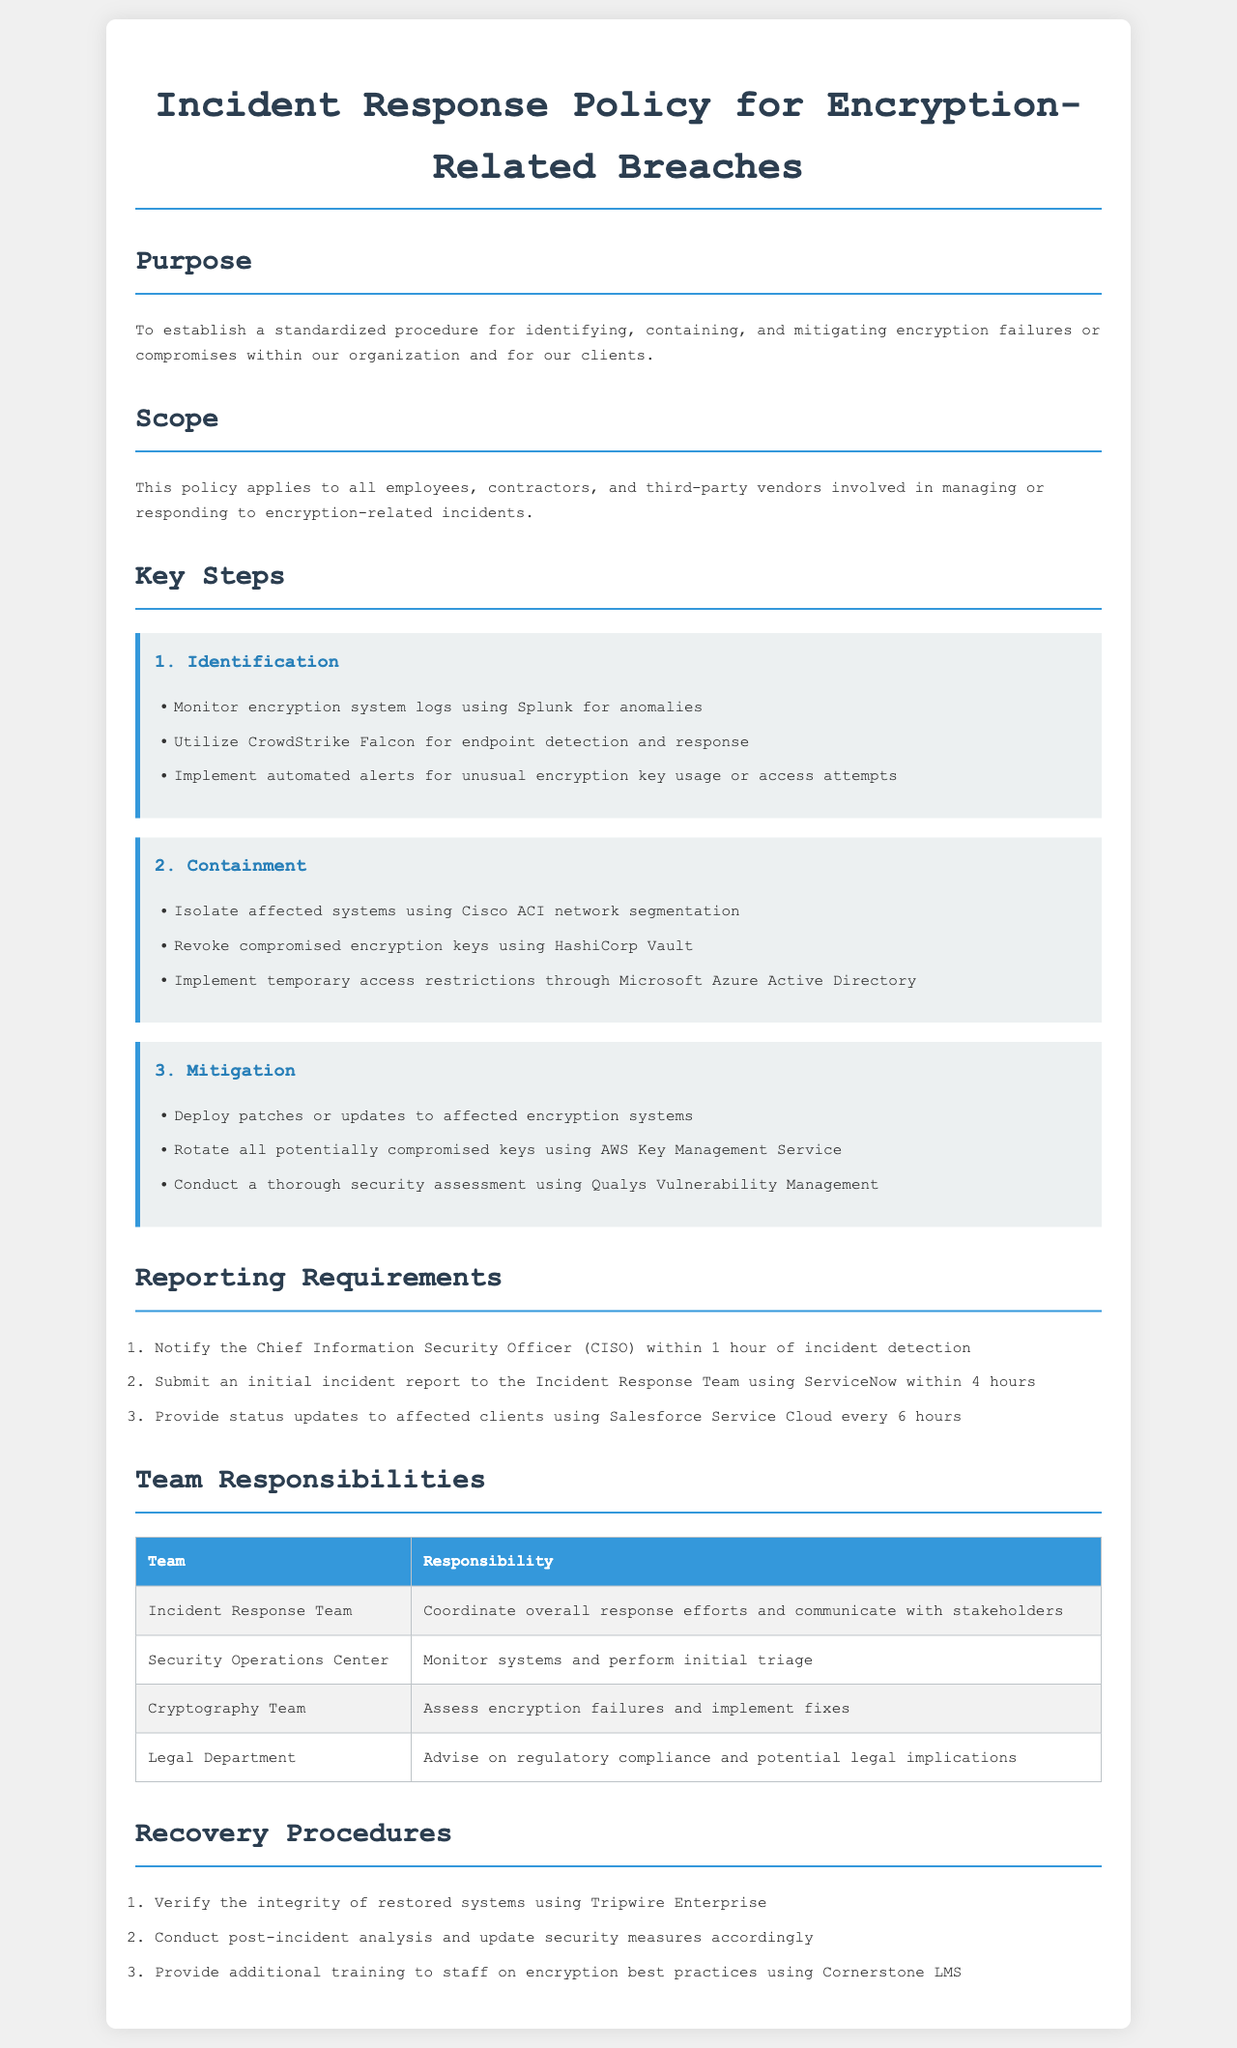What is the purpose of the policy? The purpose is to establish a standardized procedure for identifying, containing, and mitigating encryption failures or compromises within our organization.
Answer: To establish a standardized procedure Who needs to be notified within 1 hour of incident detection? The Chief Information Security Officer (CISO) is the individual who must be notified as per the reporting requirements.
Answer: Chief Information Security Officer What system is used for endpoint detection and response? CrowdStrike Falcon is the system mentioned for endpoint detection and response during the identification step.
Answer: CrowdStrike Falcon How soon should an initial incident report be submitted? The initial incident report must be submitted within 4 hours of incident detection according to the reporting requirements.
Answer: 4 hours Which team is responsible for monitoring systems? The Security Operations Center is responsible for monitoring systems as stated in the team responsibilities section.
Answer: Security Operations Center What method is used to revoke compromised encryption keys? HashiCorp Vault is the method specified for revoking compromised encryption keys during the containment step.
Answer: HashiCorp Vault What is one of the recovery procedures? Verifying the integrity of restored systems using Tripwire Enterprise is a specified recovery procedure.
Answer: Verify the integrity of restored systems What tool is implemented for unusual encryption key usage alerts? Automated alerts for unusual encryption key usage are implemented to monitor encryption systems.
Answer: Automated alerts 